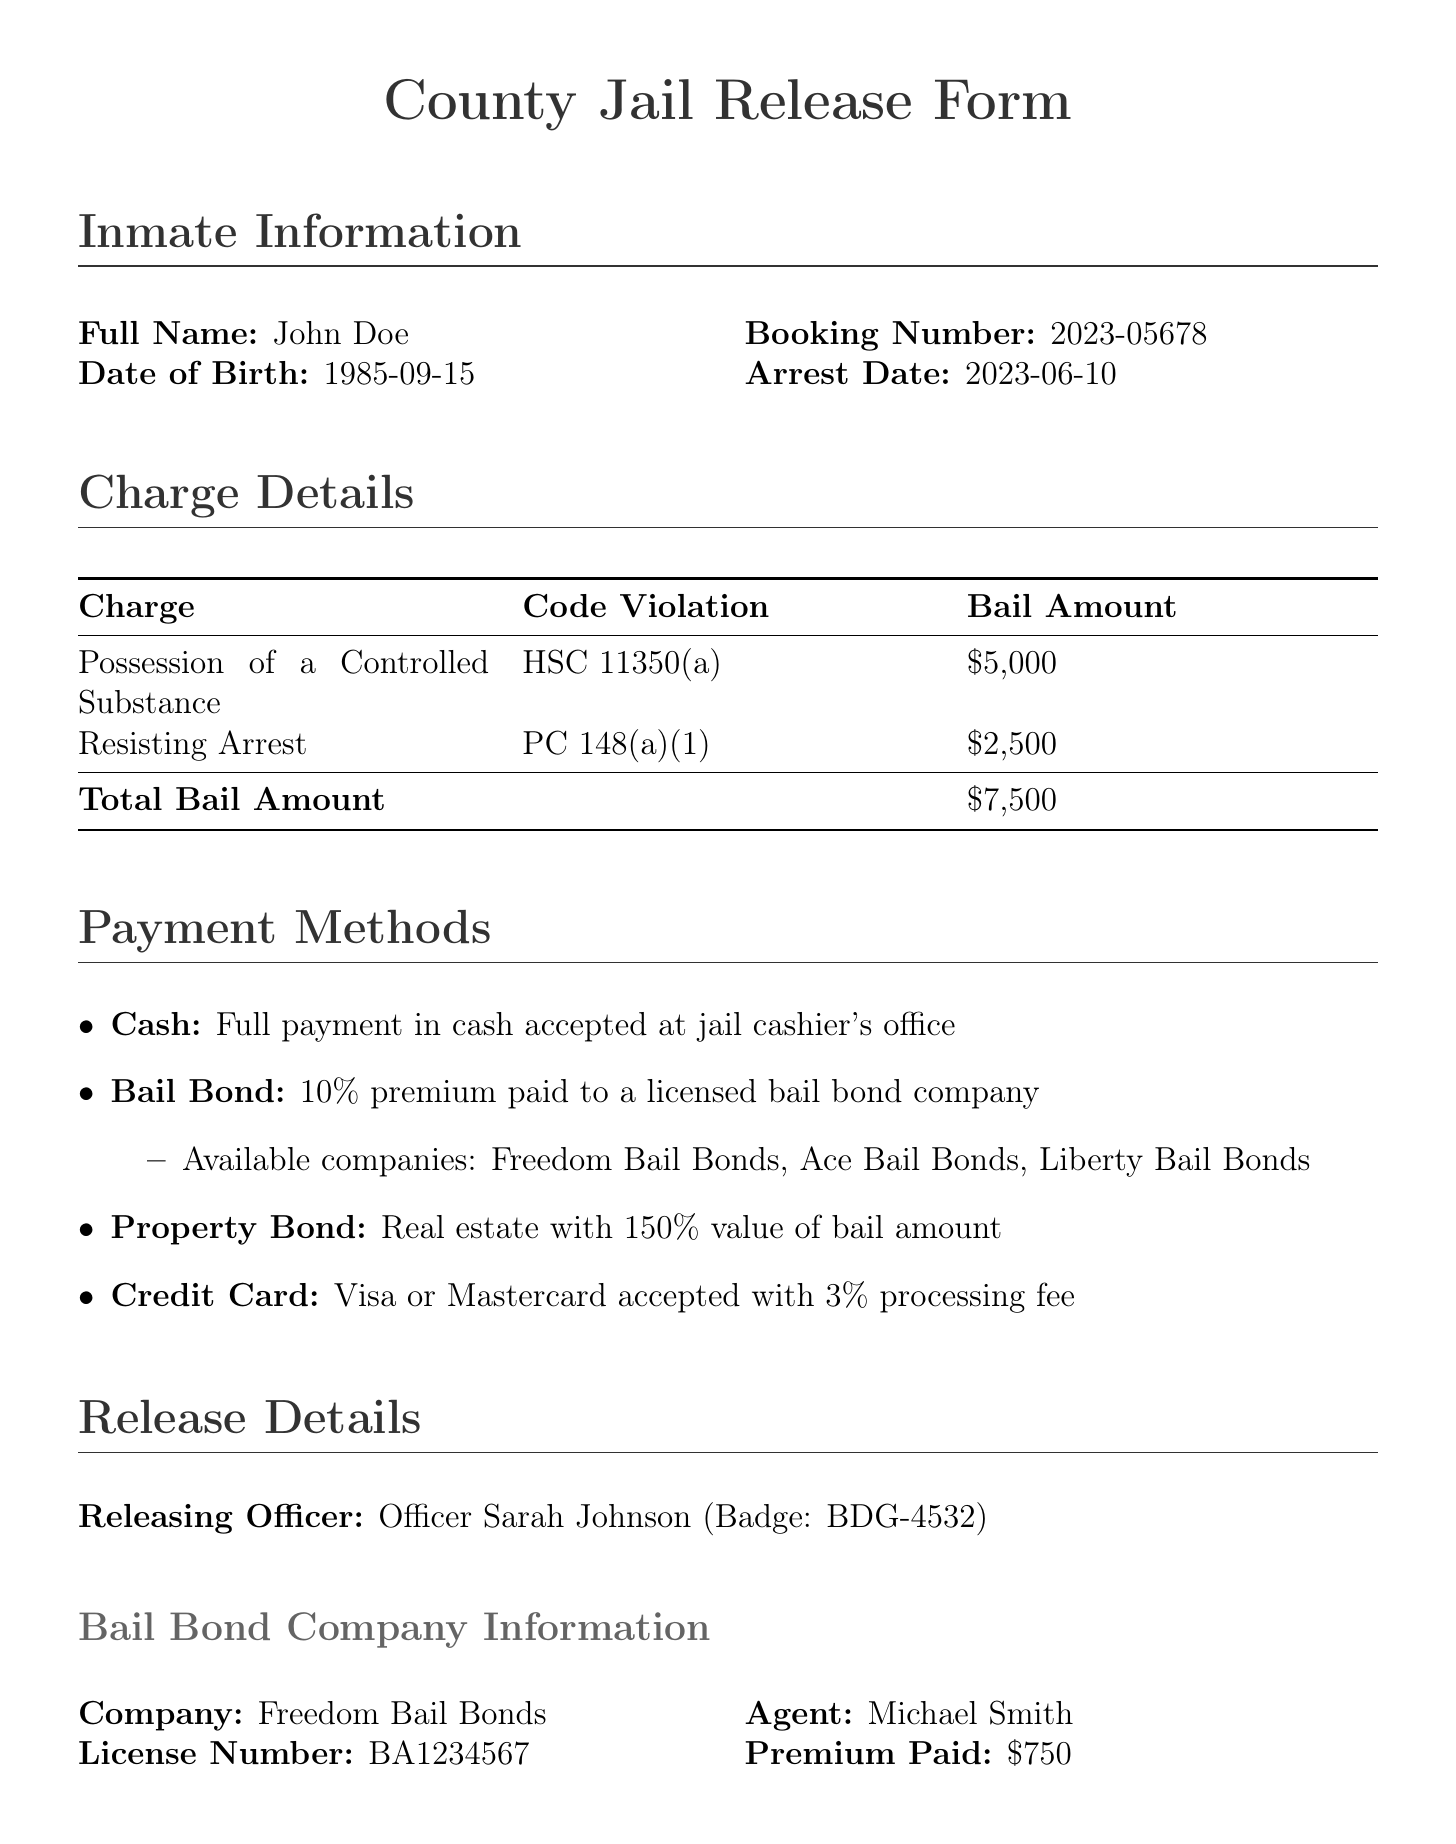What is the full name of the inmate? The full name of the inmate is found in the inmate information section of the document.
Answer: John Doe What is the booking number? The booking number is listed under inmate information in the document.
Answer: 2023-05678 What is the total bail amount? The total bail amount is calculated from the sum of all individual bail amounts listed in the charge details section.
Answer: $7500 Who is the releasing officer? The releasing officer's name is provided in the release details section of the document.
Answer: Officer Sarah Johnson What is the bail premium paid to Freedom Bail Bonds? The bail premium amount is specified under the bail bond company information in the document.
Answer: $750 What is the date of the next court appearance? The date of the next court appearance can be found in the next court appearance section of the document.
Answer: 2023-07-15 What method allows for real estate to secure bail? The payment methods section describes a type of bond that uses real estate.
Answer: Property Bond What are the consequences of failing to appear in court? The consequences are mentioned in the disclaimers section of the document.
Answer: Additional charges and forfeiture of bail What are the eligible payment methods listed? The payment methods section outlines various payment options presented in the document.
Answer: Cash, Bail Bond, Property Bond, Credit Card 